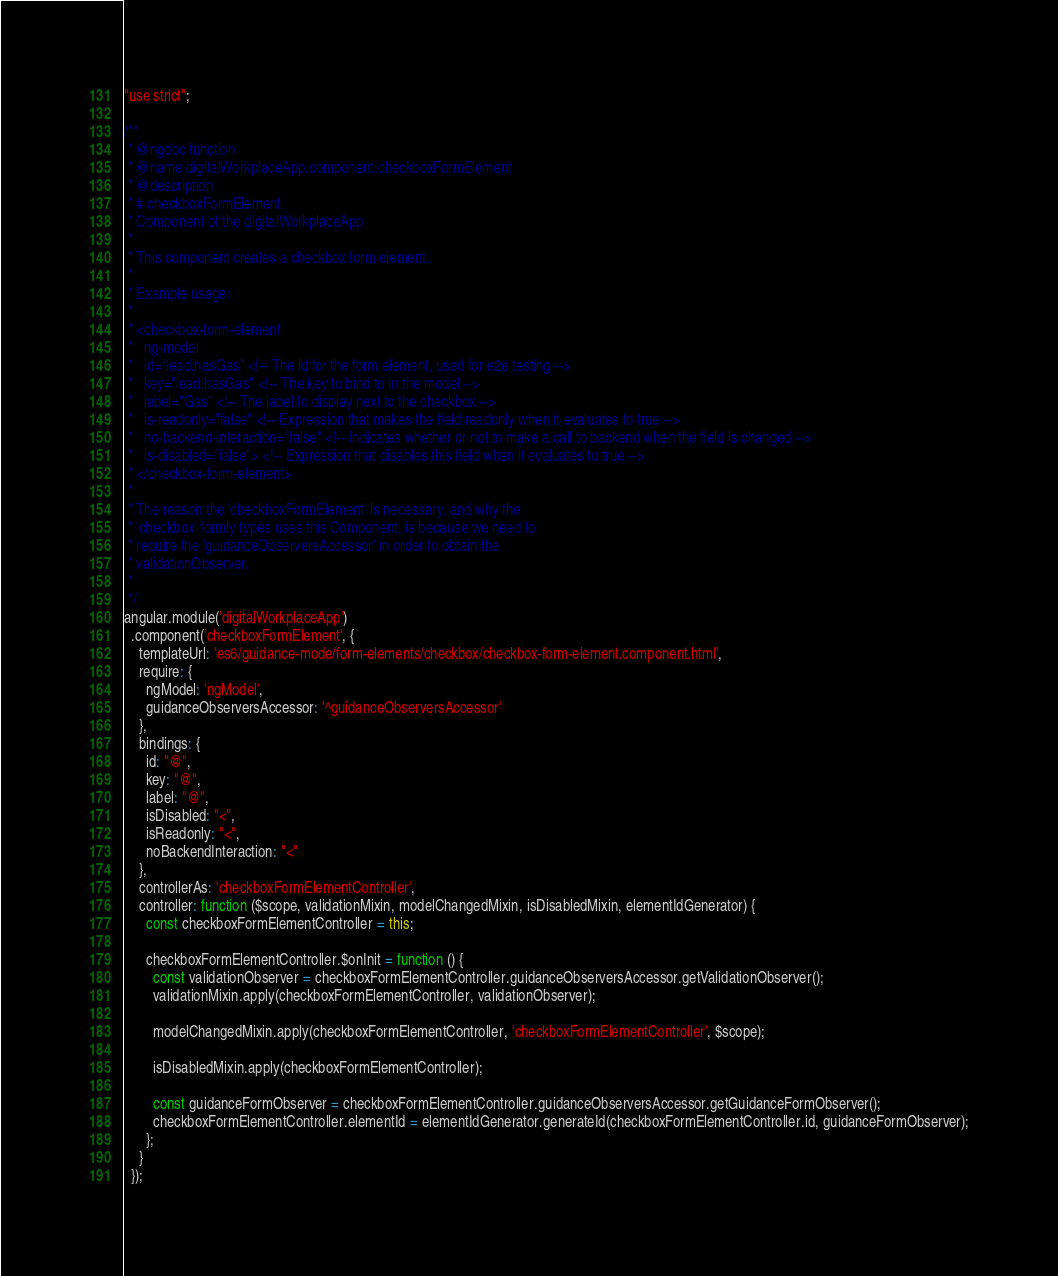Convert code to text. <code><loc_0><loc_0><loc_500><loc_500><_JavaScript_>"use strict";

/**
 * @ngdoc function
 * @name digitalWorkplaceApp.component:checkboxFormElement
 * @description
 * # checkboxFormElement
 * Component of the digitalWorkplaceApp
 *
 * This component creates a checkbox form element.
 *
 * Example usage:
 *
 * <checkbox-form-element
 *   ng-model
 *   id="lead.hasGas" <!-- The id for the form element, used for e2e testing -->
 *   key="lead.hasGas" <!-- The key to bind to in the model -->
 *   label="Gas" <!-- The label to display next to the checkbox -->
 *   is-readonly="false" <!-- Expression that makes the field readonly when it evaluates to true -->
 *   no-backend-interaction="false" <!-- Indicates whether or not to make a call to backend when the field is changed -->
 *   is-disabled="false"> <!-- Expression that disables this field when it evaluates to true -->
 * </checkbox-form-element>
 *
 * The reason the 'checkboxFormElement' is necessary, and why the
 * 'checkbox' formly types uses this Component, is because we need to
 * require the 'guidanceObserversAccessor' in order to obtain the
 * validationObserver.
 *
 */
angular.module('digitalWorkplaceApp')
  .component('checkboxFormElement', {
    templateUrl: 'es6/guidance-mode/form-elements/checkbox/checkbox-form-element.component.html',
    require: {
      ngModel: 'ngModel',
      guidanceObserversAccessor: '^guidanceObserversAccessor'
    },
    bindings: {
      id: "@",
      key: "@",
      label: "@",
      isDisabled: "<",
      isReadonly: "<",
      noBackendInteraction: "<"
    },
    controllerAs: 'checkboxFormElementController',
    controller: function ($scope, validationMixin, modelChangedMixin, isDisabledMixin, elementIdGenerator) {
      const checkboxFormElementController = this;

      checkboxFormElementController.$onInit = function () {
        const validationObserver = checkboxFormElementController.guidanceObserversAccessor.getValidationObserver();
        validationMixin.apply(checkboxFormElementController, validationObserver);

        modelChangedMixin.apply(checkboxFormElementController, 'checkboxFormElementController', $scope);

        isDisabledMixin.apply(checkboxFormElementController);

        const guidanceFormObserver = checkboxFormElementController.guidanceObserversAccessor.getGuidanceFormObserver();
        checkboxFormElementController.elementId = elementIdGenerator.generateId(checkboxFormElementController.id, guidanceFormObserver);
      };
    }
  });
</code> 